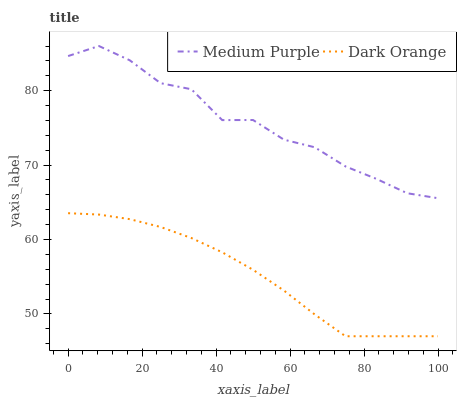Does Dark Orange have the minimum area under the curve?
Answer yes or no. Yes. Does Medium Purple have the maximum area under the curve?
Answer yes or no. Yes. Does Dark Orange have the maximum area under the curve?
Answer yes or no. No. Is Dark Orange the smoothest?
Answer yes or no. Yes. Is Medium Purple the roughest?
Answer yes or no. Yes. Is Dark Orange the roughest?
Answer yes or no. No. Does Dark Orange have the highest value?
Answer yes or no. No. Is Dark Orange less than Medium Purple?
Answer yes or no. Yes. Is Medium Purple greater than Dark Orange?
Answer yes or no. Yes. Does Dark Orange intersect Medium Purple?
Answer yes or no. No. 